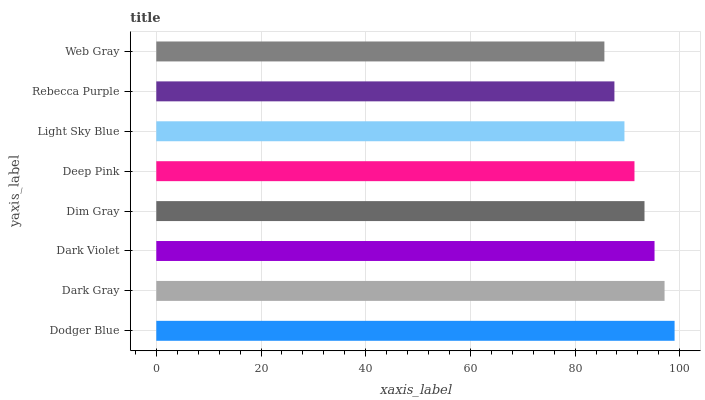Is Web Gray the minimum?
Answer yes or no. Yes. Is Dodger Blue the maximum?
Answer yes or no. Yes. Is Dark Gray the minimum?
Answer yes or no. No. Is Dark Gray the maximum?
Answer yes or no. No. Is Dodger Blue greater than Dark Gray?
Answer yes or no. Yes. Is Dark Gray less than Dodger Blue?
Answer yes or no. Yes. Is Dark Gray greater than Dodger Blue?
Answer yes or no. No. Is Dodger Blue less than Dark Gray?
Answer yes or no. No. Is Dim Gray the high median?
Answer yes or no. Yes. Is Deep Pink the low median?
Answer yes or no. Yes. Is Rebecca Purple the high median?
Answer yes or no. No. Is Dim Gray the low median?
Answer yes or no. No. 